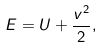<formula> <loc_0><loc_0><loc_500><loc_500>E = U + \frac { v ^ { 2 } } { 2 } ,</formula> 